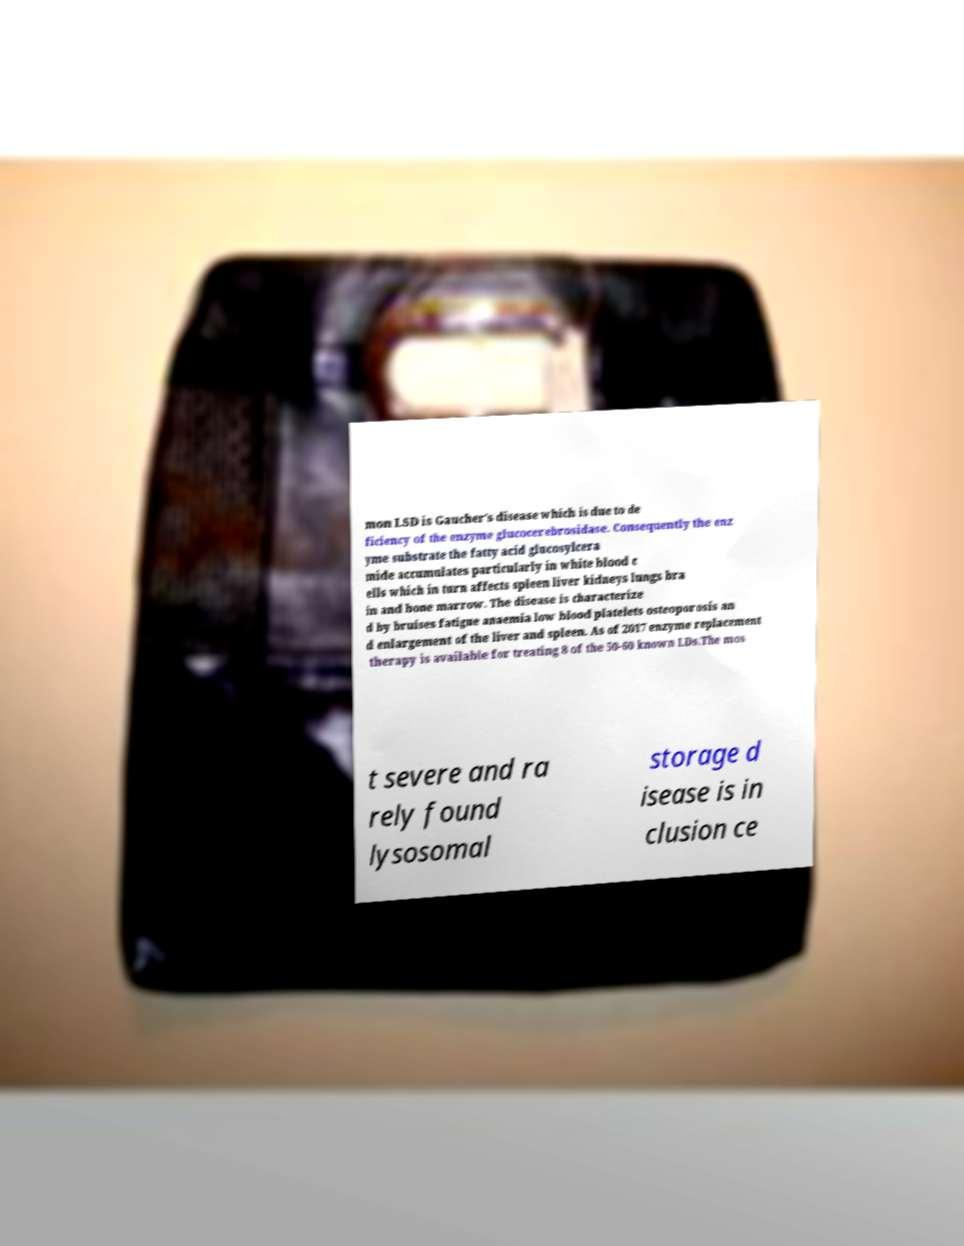Can you read and provide the text displayed in the image?This photo seems to have some interesting text. Can you extract and type it out for me? mon LSD is Gaucher's disease which is due to de ficiency of the enzyme glucocerebrosidase. Consequently the enz yme substrate the fatty acid glucosylcera mide accumulates particularly in white blood c ells which in turn affects spleen liver kidneys lungs bra in and bone marrow. The disease is characterize d by bruises fatigue anaemia low blood platelets osteoporosis an d enlargement of the liver and spleen. As of 2017 enzyme replacement therapy is available for treating 8 of the 50-60 known LDs.The mos t severe and ra rely found lysosomal storage d isease is in clusion ce 